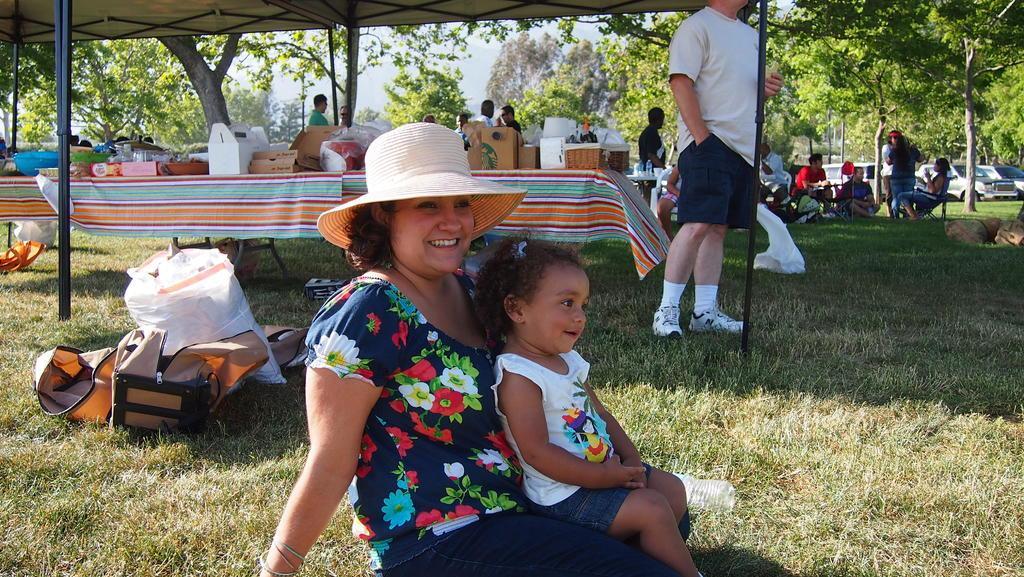Please provide a concise description of this image. In this picture there is a woman sitting and smiling and there is a baby sitting on the woman. At the back there is a person standing under the tent. On the right side of the image there are group of people sitting. In the middle of the image there are group of people standing behind the table. There are cardboard boxes and there is a basket on the table. At the back there are trees and vehicles. At the top there is sky. At the bottom there is a bag and cover on the grass. 